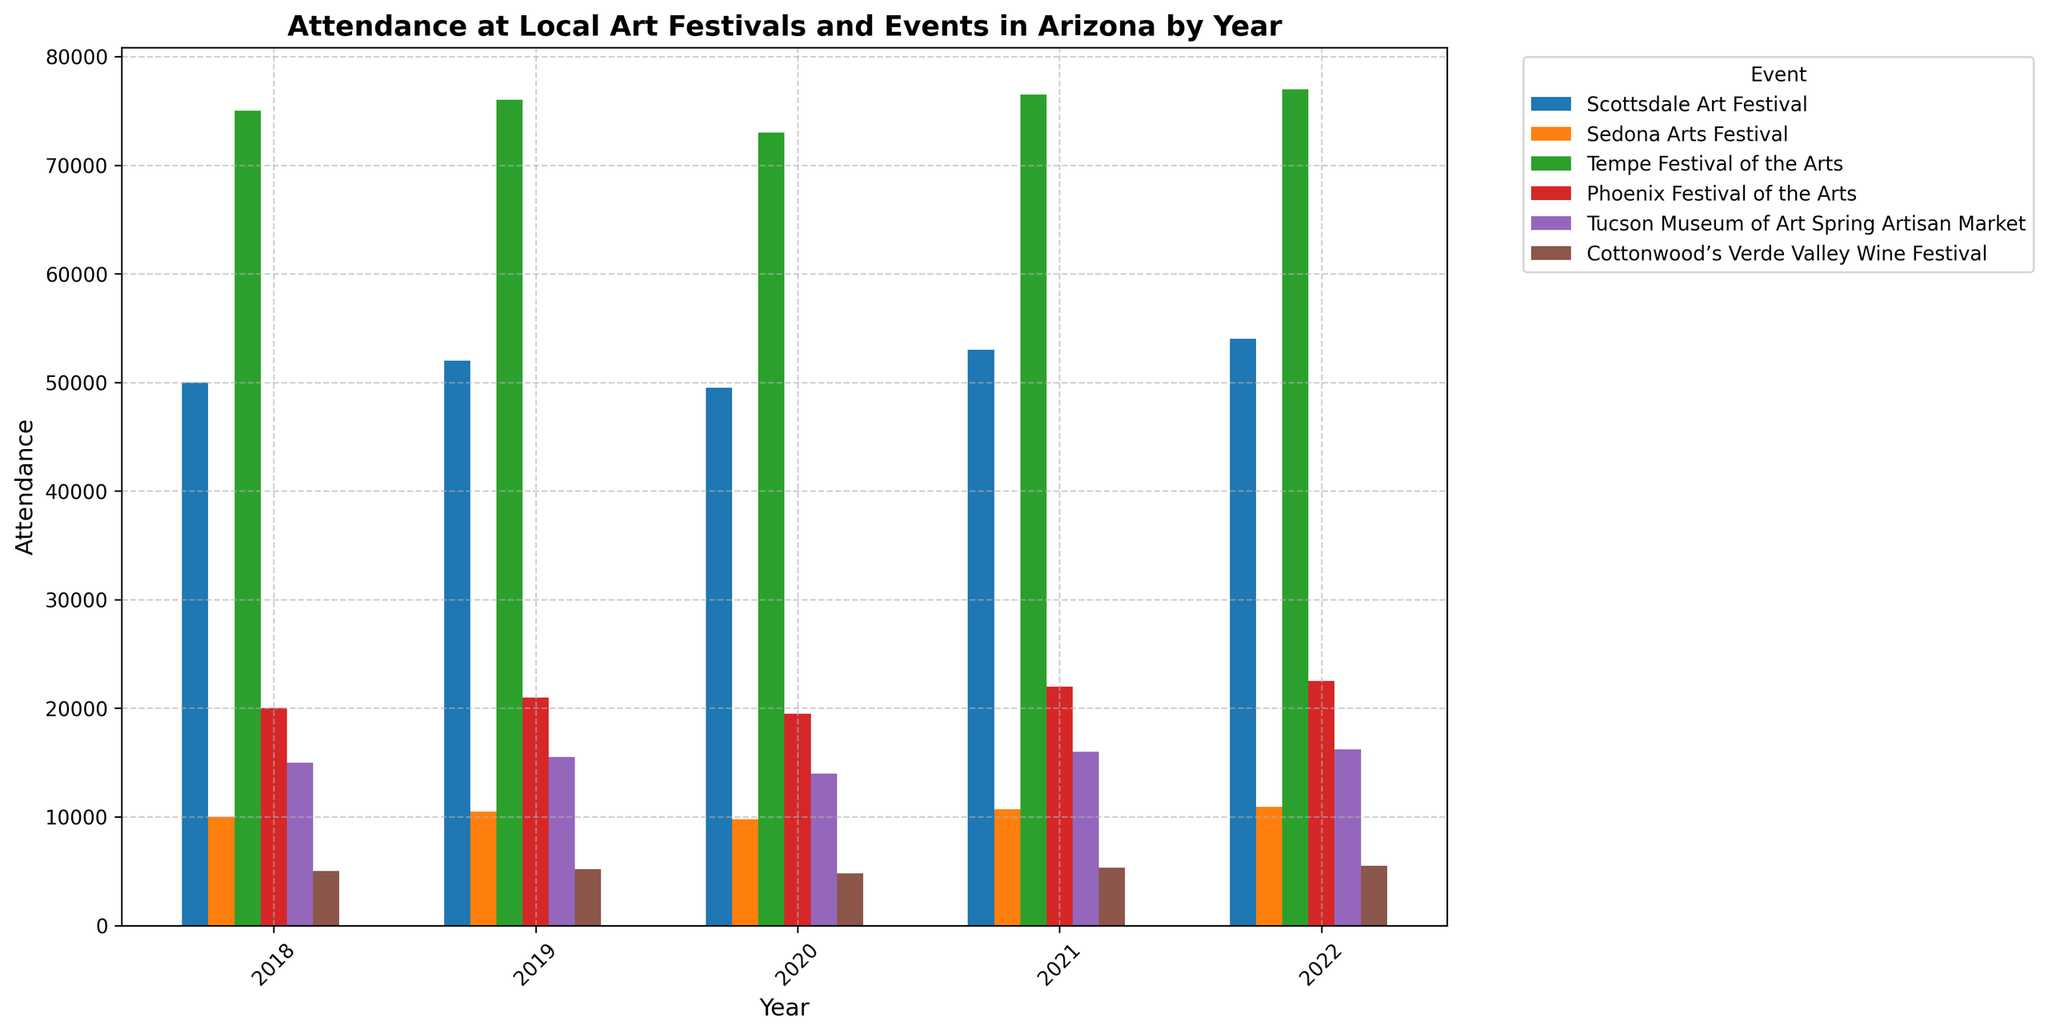Which event had the highest attendance in 2022? To find the event with the highest attendance in 2022, look at the tallest bar for 2022. The Tempe Festival of the Arts had the highest attendance, with 77,000 attendees.
Answer: Tempe Festival of the Arts Which event showed the most significant increase in attendance between 2020 and 2021? To answer this, compare the attendance bars for 2020 and 2021 for each event. The Scottsdale Art Festival increased from 49,500 in 2020 to 53,000 in 2021, which is the most significant increase of 3,500 attendees.
Answer: Scottsdale Art Festival Which years did the Tempe Festival of the Arts have higher attendance than the Scottsdale Art Festival? Compare the heights of the bars for each year for the two events. Tempe Festival of the Arts had higher attendance in all years: 2018, 2019, 2020, 2021, and 2022.
Answer: 2018, 2019, 2020, 2021, 2022 How does the attendance trend of the Cottonwood’s Verde Valley Wine Festival compare from year to year? Observe the bars for the Cottonwood’s Verde Valley Wine Festival for changes in height. The attendance fluctuated: 5,000 in 2018, 5,200 in 2019, 4,800 in 2020, 5,300 in 2021, and 5,500 in 2022, showing a general trend of fluctuating but slightly increasing over years.
Answer: Fluctuating but slightly increasing What is the average attendance of the Phoenix Festival of the Arts between 2018 and 2022? Add the attendance figures of the Phoenix Festival of the Arts for each year and divide by the number of years: (20,000 + 21,000 + 19,500 + 22,000 + 22,500) / 5 = 21,000 attendees.
Answer: 21,000 Which event had the least attendance in 2018? Look at the shortest bar for 2018. Cottonwood’s Verde Valley Wine Festival had the least attendance with 5,000 attendees.
Answer: Cottonwood’s Verde Valley Wine Festival What is the difference in attendance between the Sedona Arts Festival and the Tucson Museum of Art Spring Artisan Market in 2022? Subtract the attendance of the Tucson Museum of Art Spring Artisan Market from that of the Sedona Arts Festival in 2022: 10,900 - 16,200 = -5,300, so the Tucson Museum of Art event had 5,300 more attendees than the Sedona Arts Festival.
Answer: 5,300 For which years did the Tucson Museum of Art Spring Artisan Market have higher attendance than the Sedona Arts Festival? Compare the heights of the bars for these two events for each year. For 2019, 2021, and 2022, the Tucson Museum of Art Spring Artisan Market had higher attendance than the Sedona Arts Festival.
Answer: 2019, 2021, 2022 